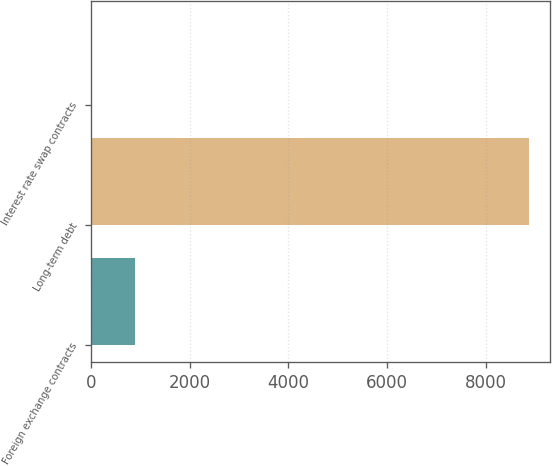Convert chart. <chart><loc_0><loc_0><loc_500><loc_500><bar_chart><fcel>Foreign exchange contracts<fcel>Long-term debt<fcel>Interest rate swap contracts<nl><fcel>896.1<fcel>8862<fcel>11<nl></chart> 